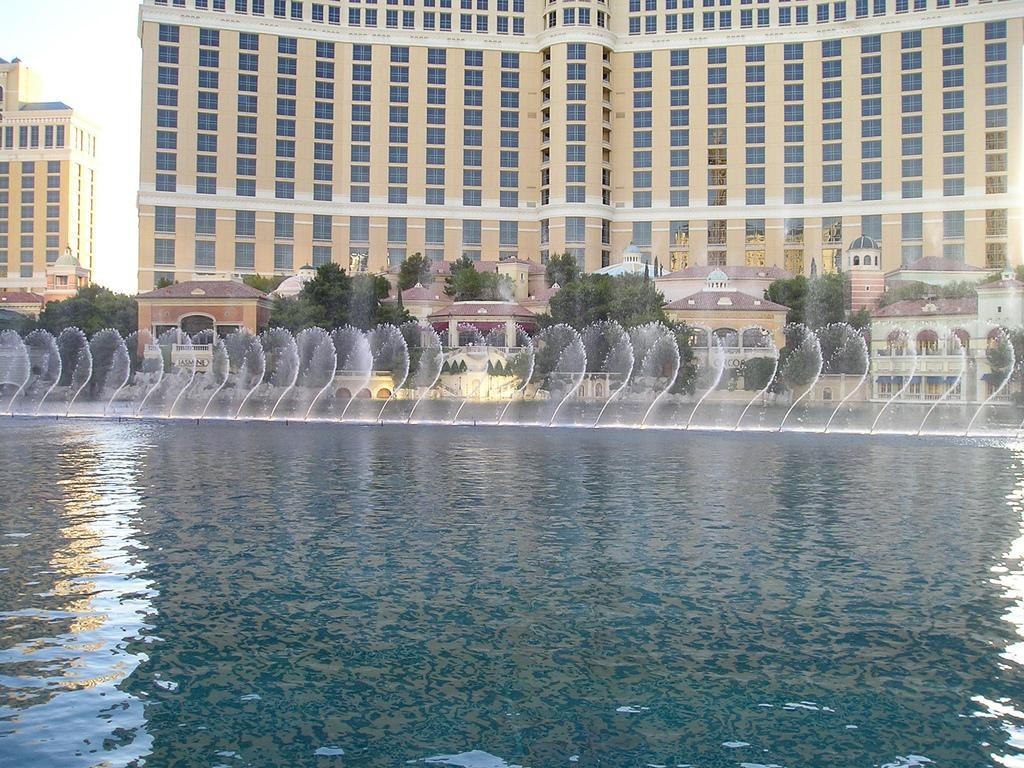What is present at the bottom of the image? There is water at the bottom of the image. What can be seen in the background of the image? There are many trees and buildings in the background of the image. What is visible at the top of the image? The sky is visible at the top of the image. How many pigs are sitting on the bottle in the image? There are no pigs or bottles present in the image. 